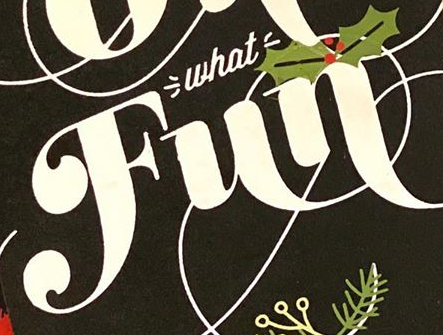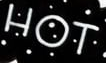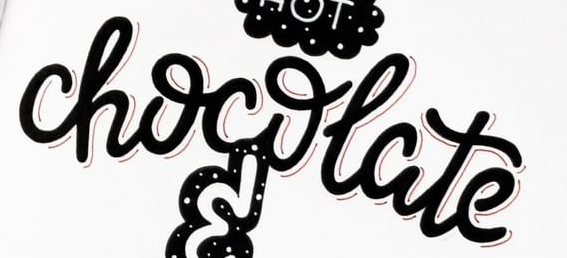What words can you see in these images in sequence, separated by a semicolon? Fun; HOT; chocolate 